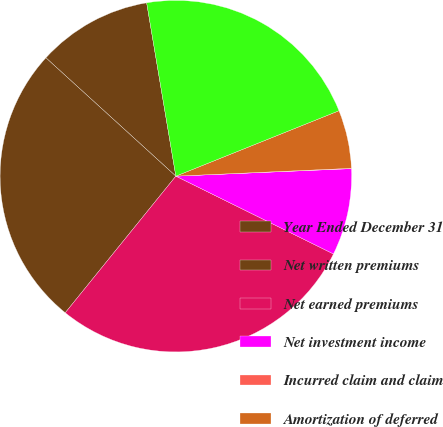Convert chart. <chart><loc_0><loc_0><loc_500><loc_500><pie_chart><fcel>Year Ended December 31<fcel>Net written premiums<fcel>Net earned premiums<fcel>Net investment income<fcel>Incurred claim and claim<fcel>Amortization of deferred<fcel>Paid claim and claim<nl><fcel>10.59%<fcel>25.93%<fcel>28.54%<fcel>7.98%<fcel>0.03%<fcel>5.36%<fcel>21.59%<nl></chart> 